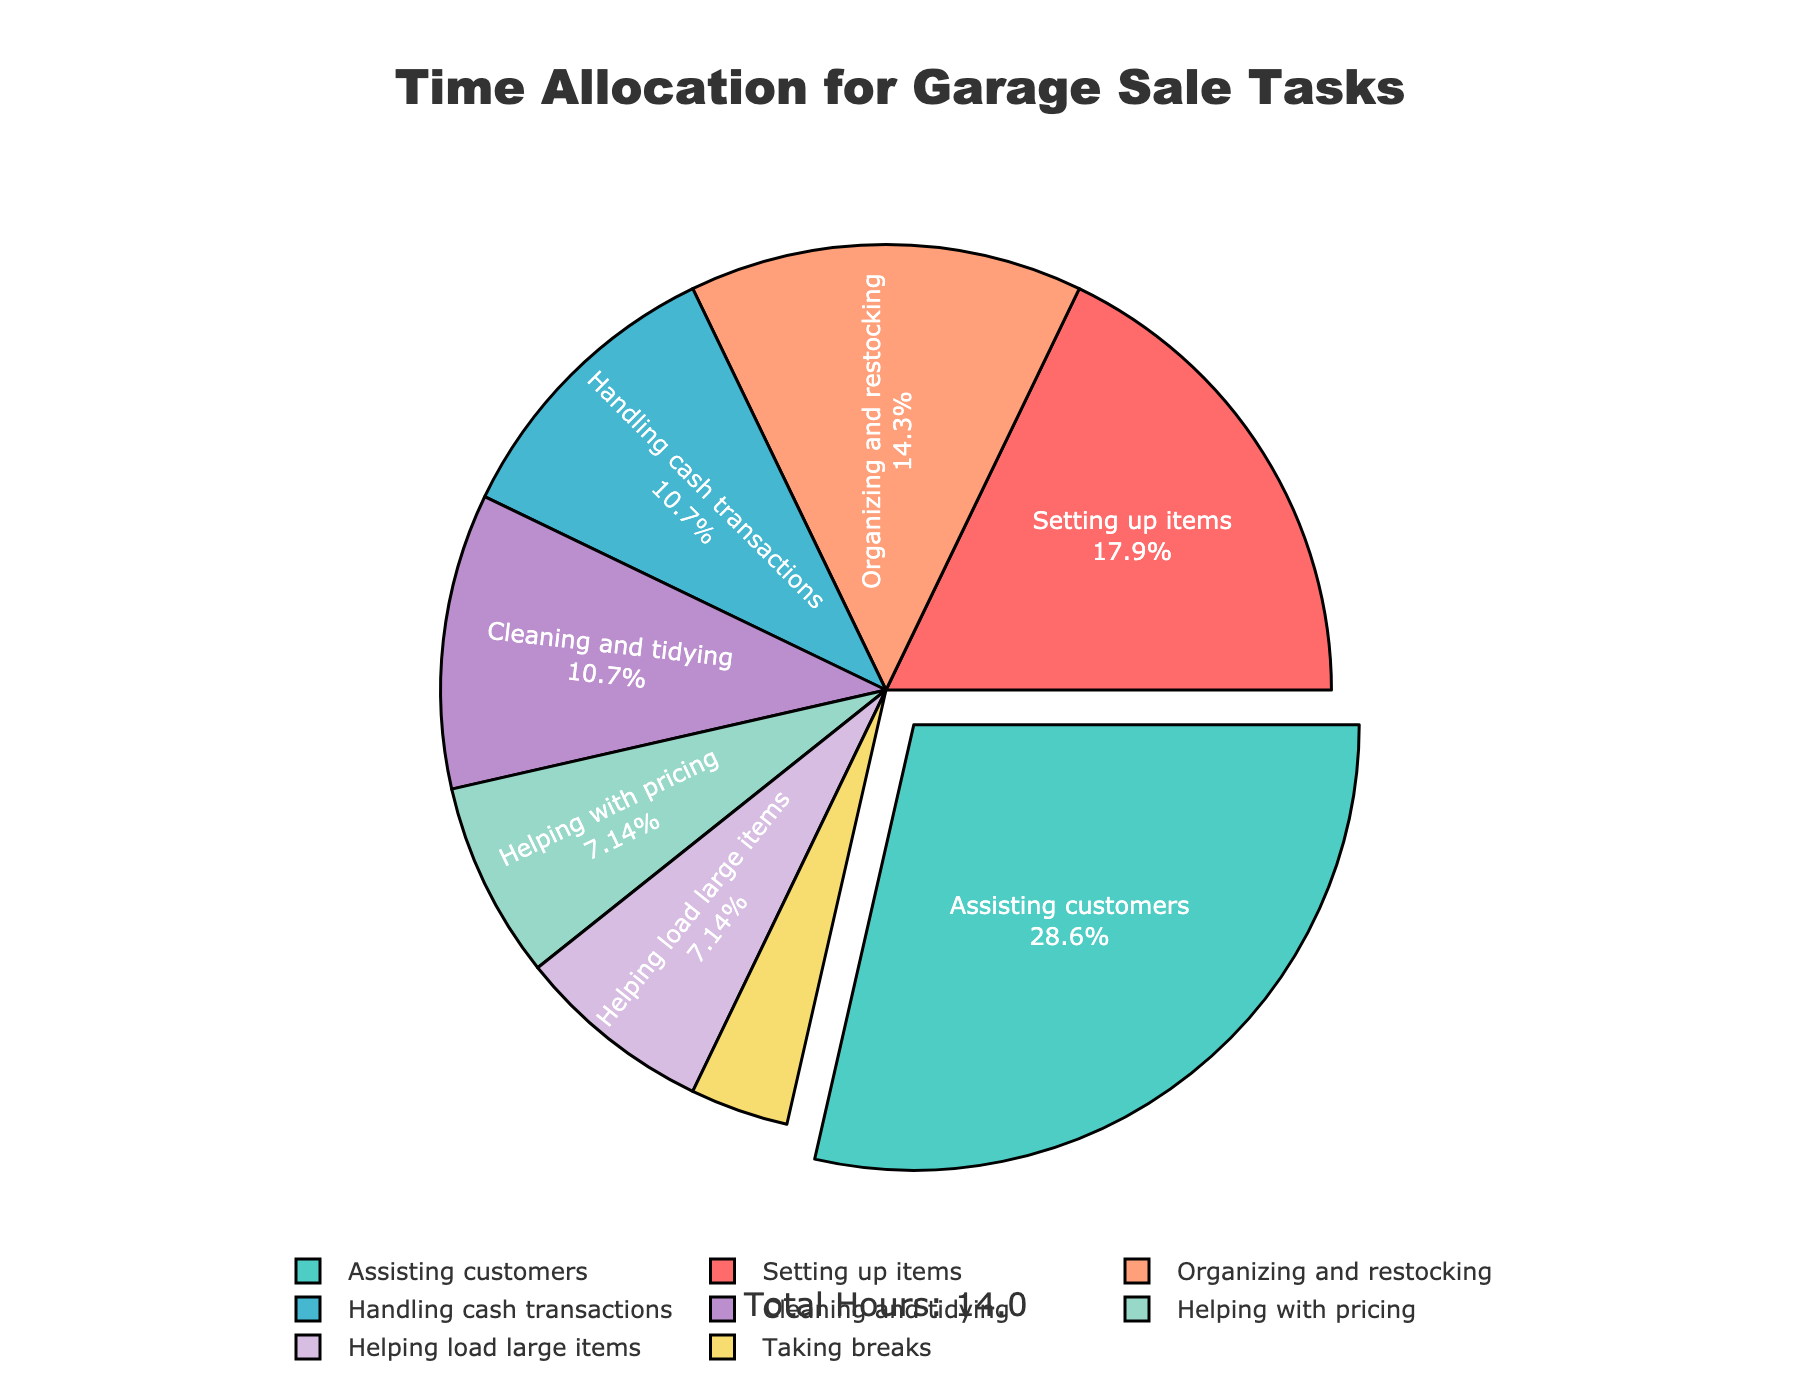What task takes up the most time during the garage sale? From the pie chart, the task with the largest section is "Assisting customers". This section is pulled out from the rest for emphasis, showing it's the most time-consuming.
Answer: Assisting customers What percentage of the time is spent on setting up items? Looking at the pie chart, the section labeled "Setting up items" shows its percentage value. This is displayed as approximately 18.2%.
Answer: 18.2% How much more time is spent assisting customers compared to handling cash transactions? The pie chart shows "Assisting customers" takes 4 hours and "Handling cash transactions" takes 1.5 hours. Subtracting the two values gives 4 - 1.5 = 2.5 hours.
Answer: 2.5 hours Which task has the smallest percentage and what is that percentage? The smallest section in the pie chart is for "Taking breaks", which is shown as 0.5 hours. Its percentage is about 3.6%, the smallest percentage among all tasks.
Answer: Taking breaks, 3.6% What is the combined percentage of time for organizing and restocking, and cleaning and tidying? The pie chart shows "Organizing and restocking" as 14.6% and "Cleaning and tidying" as about 10.9%. Adding these together gives 14.6% + 10.9% = 25.5%.
Answer: 25.5% How does the time spent on helping with pricing compare to helping load large items? The chart indicates "Helping with pricing" is 1 hour and "Helping load large items" is also 1 hour. The time spent on both tasks is equal.
Answer: Equal Which task is represented by the second largest section and what color represents it? The second largest section of the pie chart is "Setting up items". It is represented by the color red.
Answer: Setting up items, red What is the total number of hours dedicated to garage sale tasks? The annotation on the pie chart notes the total hours dedicated to garage sale tasks, which is 13 hours.
Answer: 13 hours 